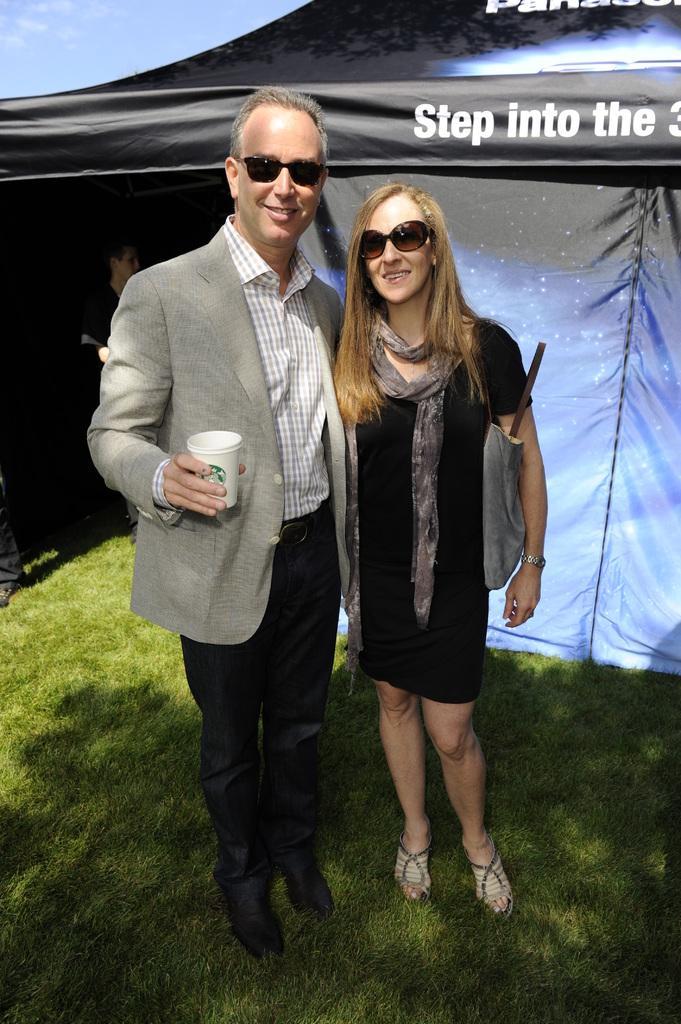In one or two sentences, can you explain what this image depicts? In this picture I can see there is a man and a woman standing. The man is holding a cup and in the backdrop there is a tent in the backdrop and there is grass on the floor. The sky is clear. 